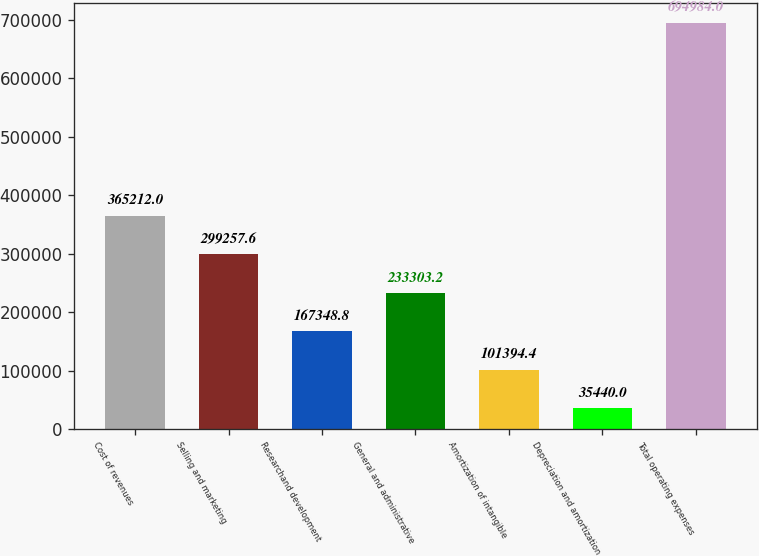Convert chart to OTSL. <chart><loc_0><loc_0><loc_500><loc_500><bar_chart><fcel>Cost of revenues<fcel>Selling and marketing<fcel>Researchand development<fcel>General and administrative<fcel>Amortization of intangible<fcel>Depreciation and amortization<fcel>Total operating expenses<nl><fcel>365212<fcel>299258<fcel>167349<fcel>233303<fcel>101394<fcel>35440<fcel>694984<nl></chart> 